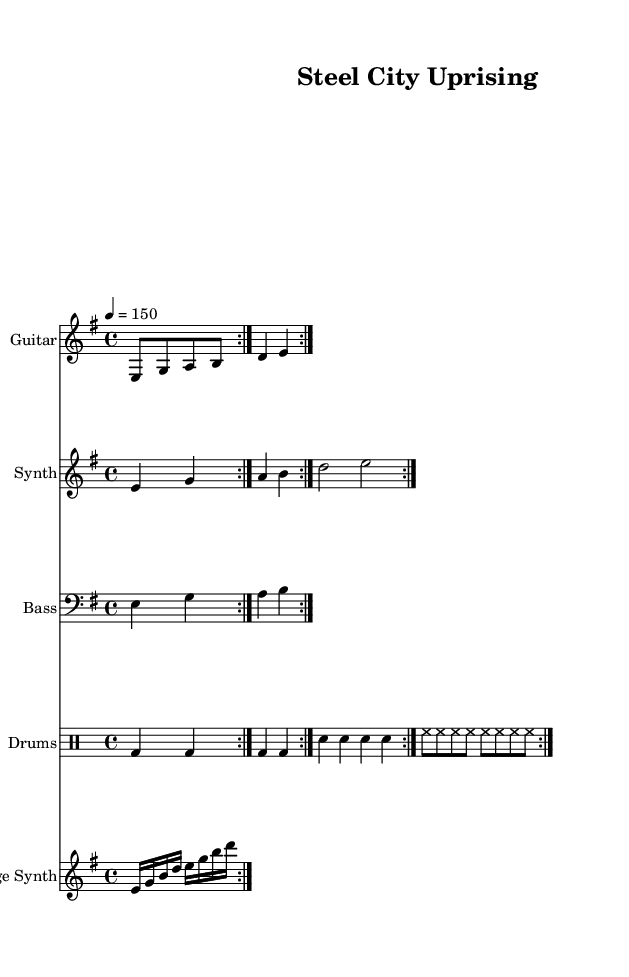What is the key signature of this music? The key signature is E minor, which has one sharp (F#). This can be determined by looking at the key signature section at the beginning of the score.
Answer: E minor What is the time signature of this music? The time signature is 4/4, indicating there are four beats in each measure. This information is found in the time signature section at the start of the score.
Answer: 4/4 What is the tempo marking of this piece? The tempo marking is quarter note equals 150. This notation is located at the beginning of the score, indicating the speed of the performance.
Answer: 150 How many times is the guitar riff repeated? The guitar riff is repeated four times. This is shown by the "repeat volta" indication at the beginning of the guitar section, which specifies the number of repetitions.
Answer: 4 What instrument plays the synth melody? The synth melody is played by a synthesizer, as indicated by the instrument name in the corresponding staff.
Answer: Synth Which instrument has a bass clef? The bass line staff has a bass clef, evident from the clef symbol at the beginning of that staff.
Answer: Bass Describe the structure of the bridge synth part. The bridge synth part consists of arpeggios played in a 16th note rhythm, as indicated by the notation in that staff. This style gives a flowing texture contrasting with the heavy guitar riffs.
Answer: Arpeggios 